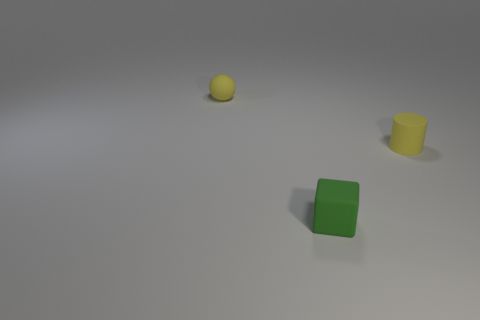Is there anything else that is the same shape as the small green thing?
Your response must be concise. No. The small matte object that is both behind the green rubber block and in front of the sphere is what color?
Offer a very short reply. Yellow. How many small matte cylinders are the same color as the tiny sphere?
Provide a succinct answer. 1. What number of big things are either yellow cylinders or brown metallic cylinders?
Your response must be concise. 0. The rubber object that is in front of the small yellow matte cylinder is what color?
Provide a short and direct response. Green. Is there another yellow matte sphere that has the same size as the ball?
Your response must be concise. No. Is the number of small cylinders that are in front of the green cube the same as the number of small things?
Provide a succinct answer. No. Is the size of the green cube the same as the matte cylinder?
Make the answer very short. Yes. Are there any small balls left of the small yellow matte thing that is in front of the yellow object to the left of the yellow cylinder?
Ensure brevity in your answer.  Yes. There is a object right of the tiny green thing; how many small matte things are behind it?
Provide a short and direct response. 1. 